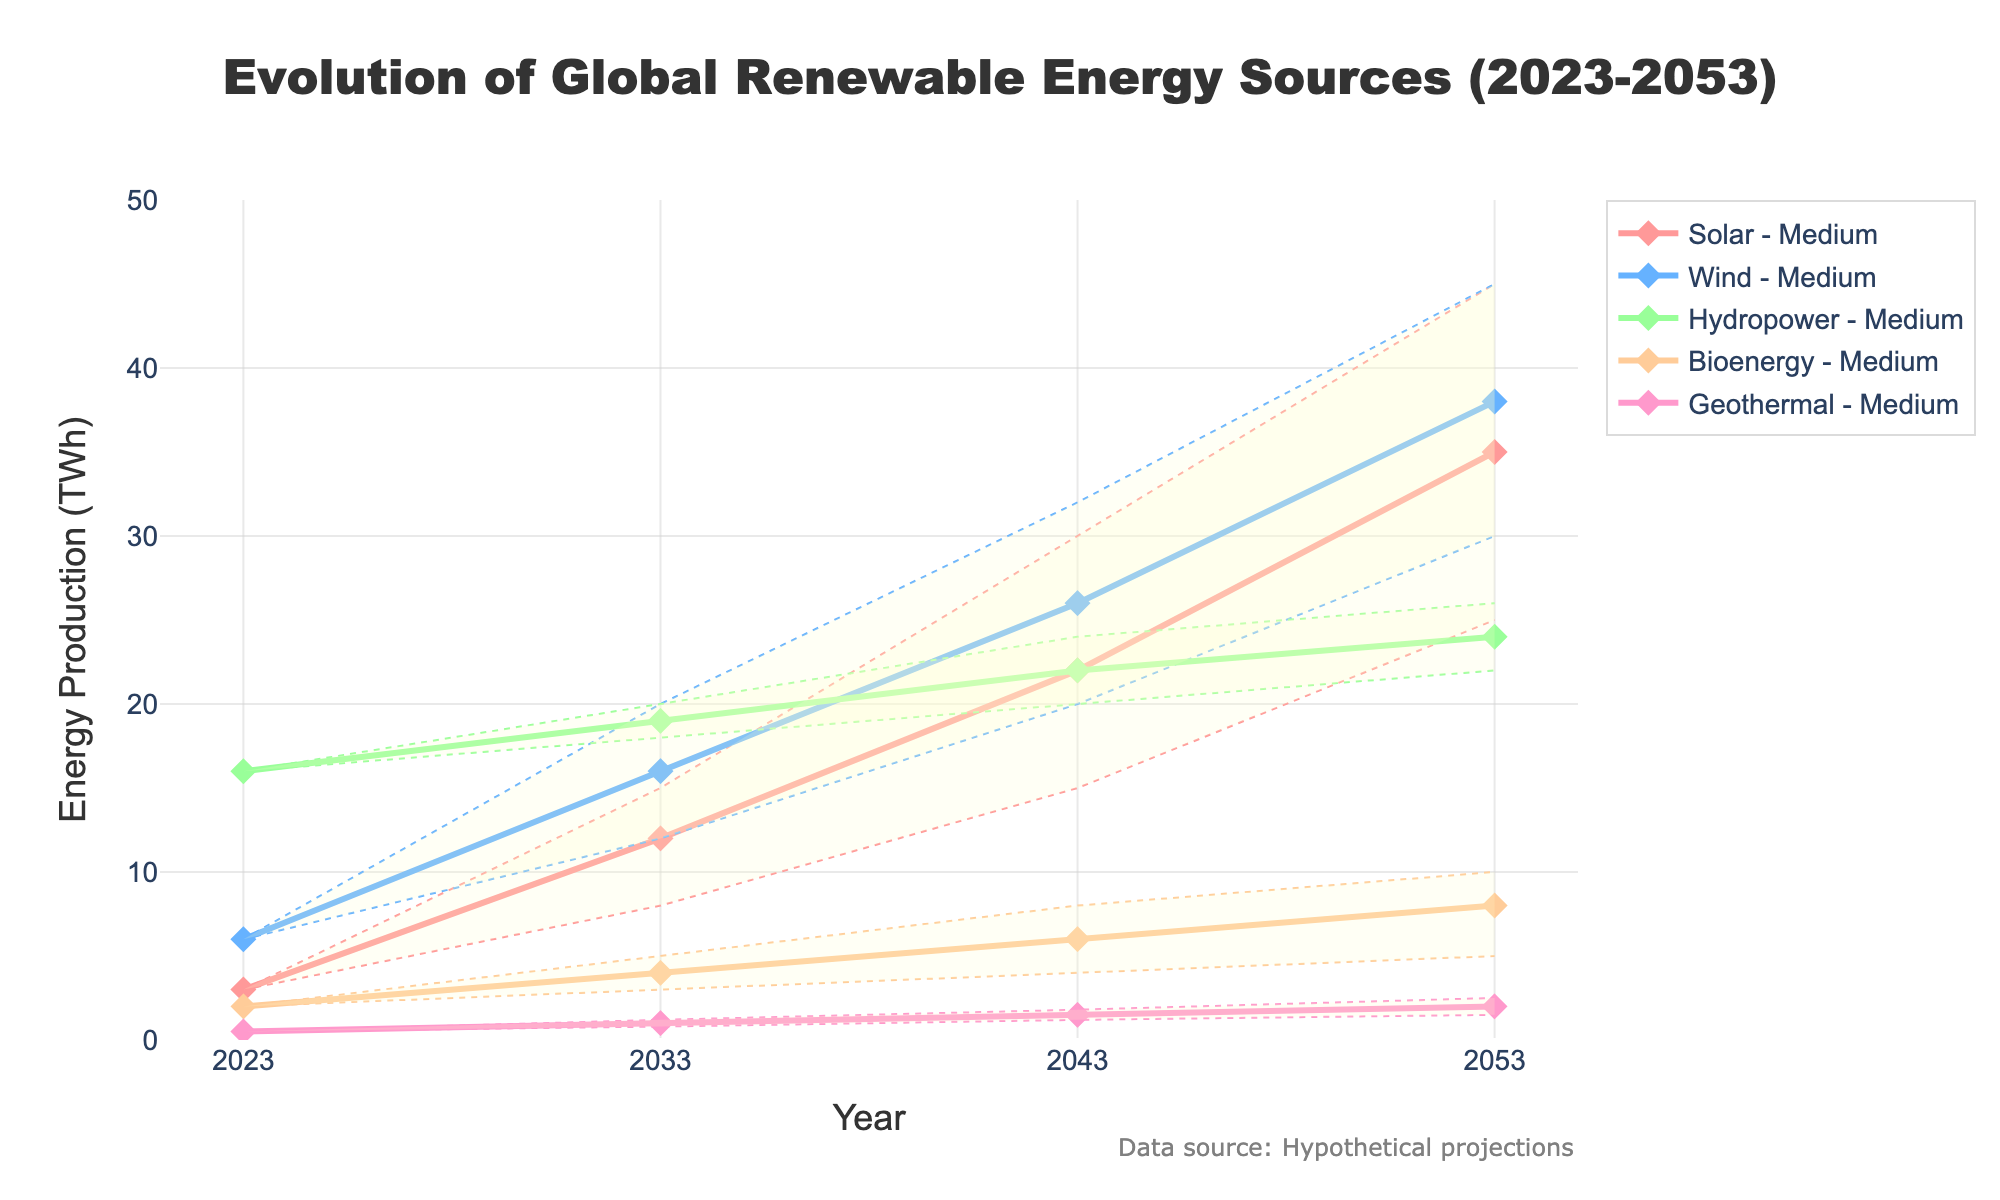What is the title of the figure? The title is the text at the top of the figure that summarizes what the figure is about.
Answer: Evolution of Global Renewable Energy Sources (2023-2053) What is the range of years shown on the x-axis? The x-axis represents the years, and you can see the labeled ticks showing the range.
Answer: 2023 to 2053 What are the five types of renewable energy sources shown in the figure? Look at the legend to identify the different renewable energy sources.
Answer: Solar, Wind, Hydropower, Bioenergy, Geothermal In 2033, according to the medium scenario, how much energy (in TWh) is expected to be generated from wind? Follow the year 2033 on the x-axis and refer to the line corresponding to Wind in the medium scenario.
Answer: 16 TWh Which renewable energy source is expected to see the highest increase in production from 2023 to 2053 in the high scenario? Compare the starting and ending points within the high scenario lines for each energy source to see which one increases the most.
Answer: Solar What is the difference in hydropower energy production between the low and high scenarios in 2043? Locate the hydropower values for both low and high scenarios in 2043 and subtract the smaller value from the larger one.
Answer: 4 TWh Which renewable energy source has the narrowest uncertainty range (difference between high and low scenarios) in 2053? Compare the difference between high and low scenario values for each energy source at 2053 and find the smallest difference.
Answer: Geothermal In the medium scenario, what is the average expected energy production of Bioenergy from 2023 to 2053? Sum the Bioenergy values for the medium scenario across all years and divide by the number of years. Calculation: (2 + 4 + 6 + 8) / 4 = 5
Answer: 5 TWh What does the shaded area represent in the fan chart? The shaded area between the lines indicates the uncertainty range, showing the potential variation from low to high scenarios.
Answer: Uncertainty range By how much is solar energy production expected to increase in the low scenario from 2033 to 2043? Subtract the solar energy value in 2033 from the value in 2043 in the low scenario.
Answer: 7 TWh 